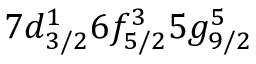<formula> <loc_0><loc_0><loc_500><loc_500>7 d _ { 3 / 2 } ^ { 1 } 6 f _ { 5 / 2 } ^ { 3 } 5 g _ { 9 / 2 } ^ { 5 }</formula> 